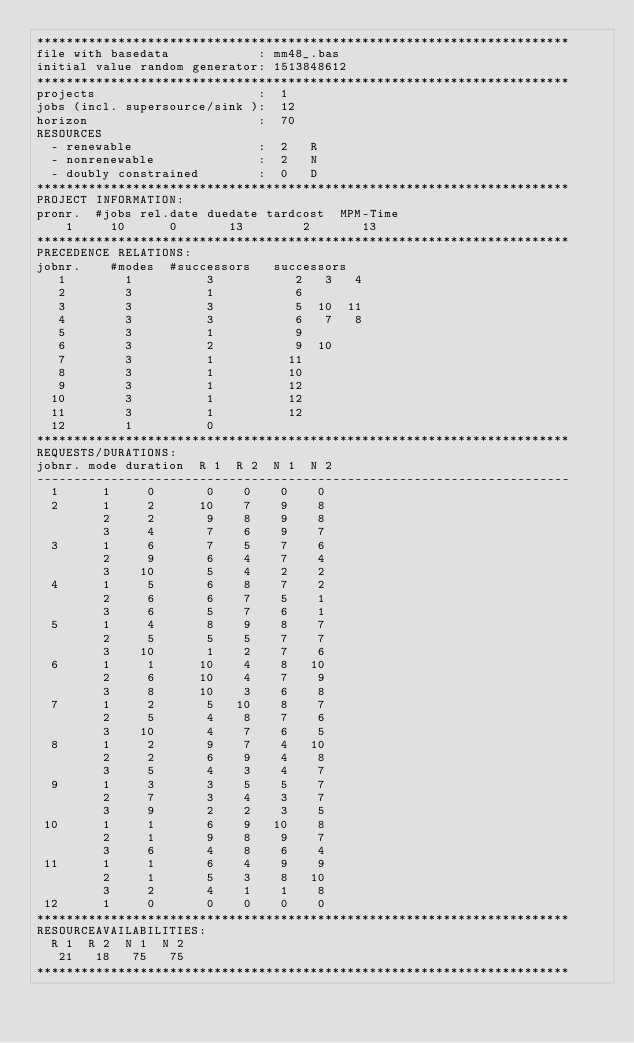<code> <loc_0><loc_0><loc_500><loc_500><_ObjectiveC_>************************************************************************
file with basedata            : mm48_.bas
initial value random generator: 1513848612
************************************************************************
projects                      :  1
jobs (incl. supersource/sink ):  12
horizon                       :  70
RESOURCES
  - renewable                 :  2   R
  - nonrenewable              :  2   N
  - doubly constrained        :  0   D
************************************************************************
PROJECT INFORMATION:
pronr.  #jobs rel.date duedate tardcost  MPM-Time
    1     10      0       13        2       13
************************************************************************
PRECEDENCE RELATIONS:
jobnr.    #modes  #successors   successors
   1        1          3           2   3   4
   2        3          1           6
   3        3          3           5  10  11
   4        3          3           6   7   8
   5        3          1           9
   6        3          2           9  10
   7        3          1          11
   8        3          1          10
   9        3          1          12
  10        3          1          12
  11        3          1          12
  12        1          0        
************************************************************************
REQUESTS/DURATIONS:
jobnr. mode duration  R 1  R 2  N 1  N 2
------------------------------------------------------------------------
  1      1     0       0    0    0    0
  2      1     2      10    7    9    8
         2     2       9    8    9    8
         3     4       7    6    9    7
  3      1     6       7    5    7    6
         2     9       6    4    7    4
         3    10       5    4    2    2
  4      1     5       6    8    7    2
         2     6       6    7    5    1
         3     6       5    7    6    1
  5      1     4       8    9    8    7
         2     5       5    5    7    7
         3    10       1    2    7    6
  6      1     1      10    4    8   10
         2     6      10    4    7    9
         3     8      10    3    6    8
  7      1     2       5   10    8    7
         2     5       4    8    7    6
         3    10       4    7    6    5
  8      1     2       9    7    4   10
         2     2       6    9    4    8
         3     5       4    3    4    7
  9      1     3       3    5    5    7
         2     7       3    4    3    7
         3     9       2    2    3    5
 10      1     1       6    9   10    8
         2     1       9    8    9    7
         3     6       4    8    6    4
 11      1     1       6    4    9    9
         2     1       5    3    8   10
         3     2       4    1    1    8
 12      1     0       0    0    0    0
************************************************************************
RESOURCEAVAILABILITIES:
  R 1  R 2  N 1  N 2
   21   18   75   75
************************************************************************
</code> 